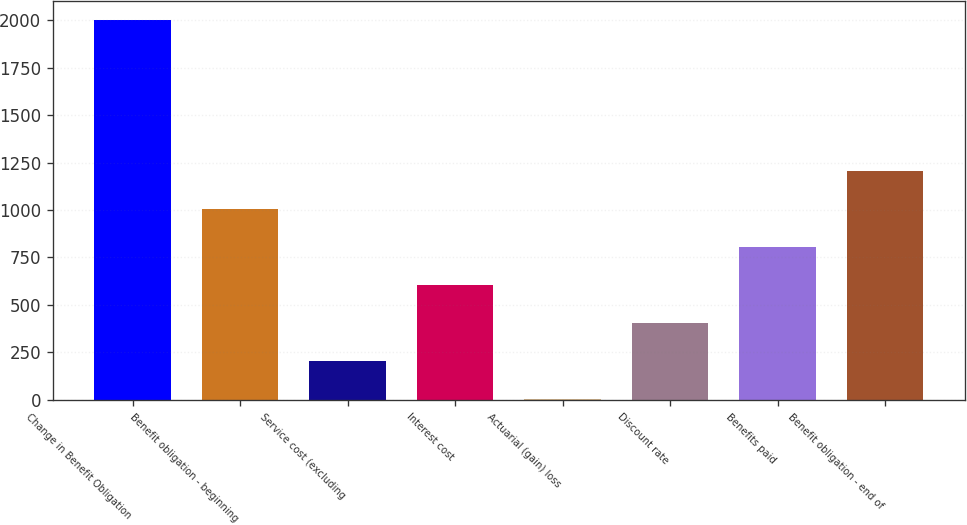Convert chart. <chart><loc_0><loc_0><loc_500><loc_500><bar_chart><fcel>Change in Benefit Obligation<fcel>Benefit obligation - beginning<fcel>Service cost (excluding<fcel>Interest cost<fcel>Actuarial (gain) loss<fcel>Discount rate<fcel>Benefits paid<fcel>Benefit obligation - end of<nl><fcel>2003<fcel>1004<fcel>204.8<fcel>604.4<fcel>5<fcel>404.6<fcel>804.2<fcel>1203.8<nl></chart> 